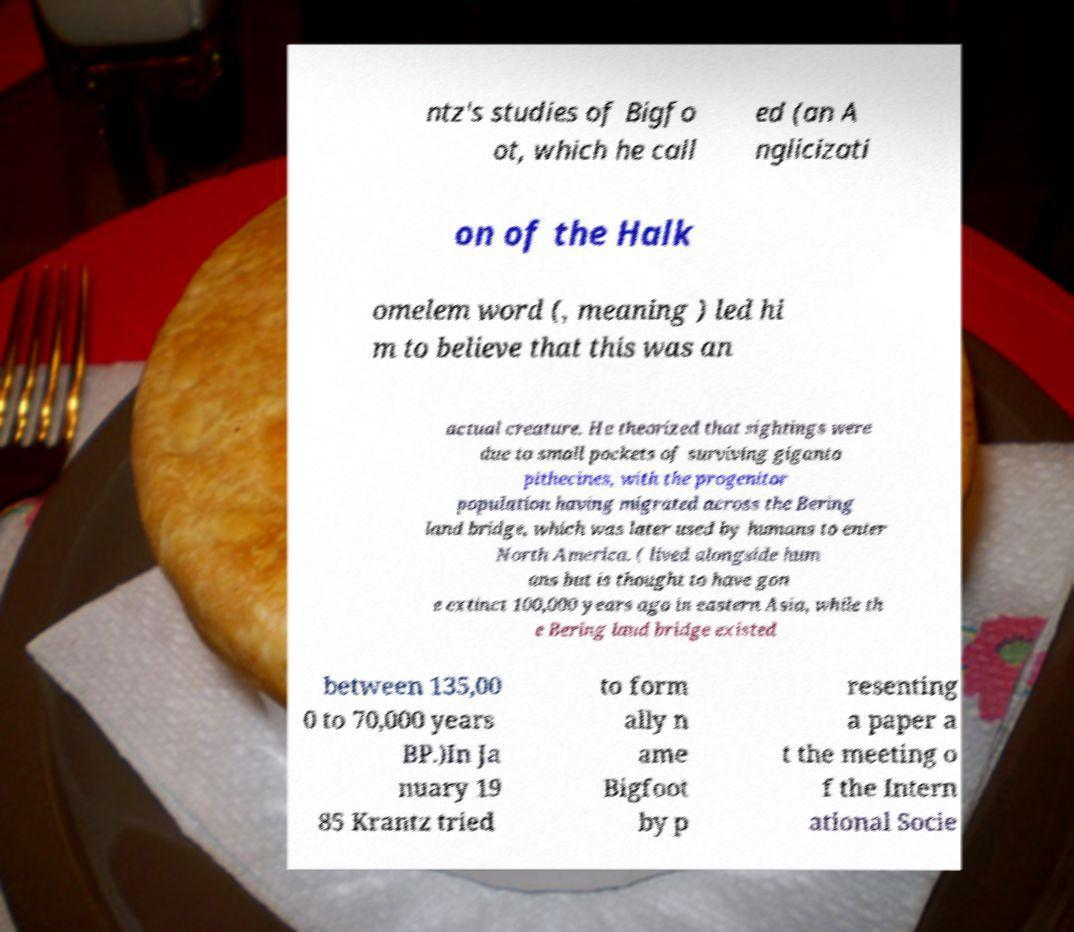I need the written content from this picture converted into text. Can you do that? ntz's studies of Bigfo ot, which he call ed (an A nglicizati on of the Halk omelem word (, meaning ) led hi m to believe that this was an actual creature. He theorized that sightings were due to small pockets of surviving giganto pithecines, with the progenitor population having migrated across the Bering land bridge, which was later used by humans to enter North America. ( lived alongside hum ans but is thought to have gon e extinct 100,000 years ago in eastern Asia, while th e Bering land bridge existed between 135,00 0 to 70,000 years BP.)In Ja nuary 19 85 Krantz tried to form ally n ame Bigfoot by p resenting a paper a t the meeting o f the Intern ational Socie 